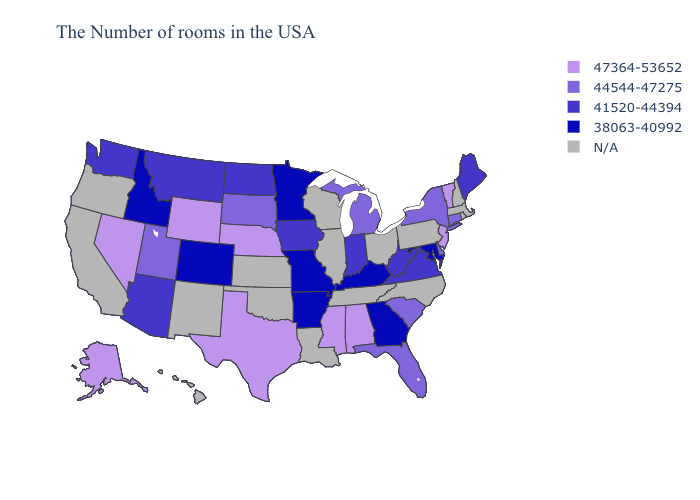Among the states that border West Virginia , which have the highest value?
Keep it brief. Virginia. What is the highest value in the USA?
Concise answer only. 47364-53652. Name the states that have a value in the range N/A?
Keep it brief. Massachusetts, Rhode Island, New Hampshire, Pennsylvania, North Carolina, Ohio, Tennessee, Wisconsin, Illinois, Louisiana, Kansas, Oklahoma, New Mexico, California, Oregon, Hawaii. What is the lowest value in states that border Alabama?
Write a very short answer. 38063-40992. What is the lowest value in the USA?
Be succinct. 38063-40992. What is the value of Massachusetts?
Concise answer only. N/A. Name the states that have a value in the range 38063-40992?
Write a very short answer. Maryland, Georgia, Kentucky, Missouri, Arkansas, Minnesota, Colorado, Idaho. Is the legend a continuous bar?
Write a very short answer. No. Which states have the lowest value in the Northeast?
Write a very short answer. Maine. What is the value of New York?
Write a very short answer. 44544-47275. Does Arkansas have the lowest value in the USA?
Write a very short answer. Yes. 